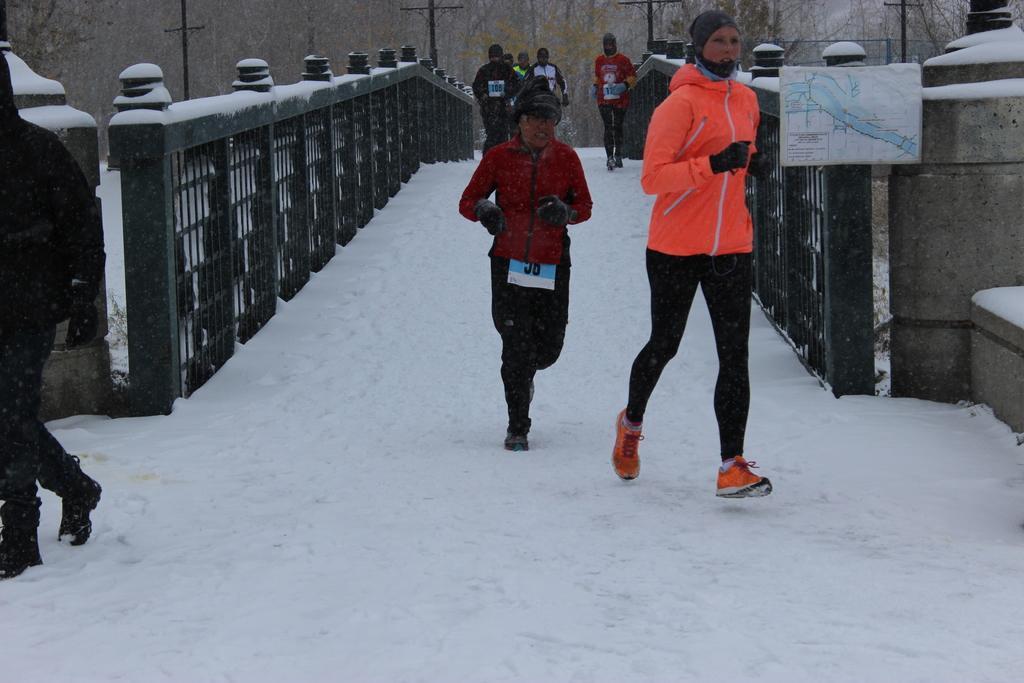In one or two sentences, can you explain what this image depicts? In this image there are group of people walking on the snow, there is a map, and in the background there are trees , poles and a bridge. 